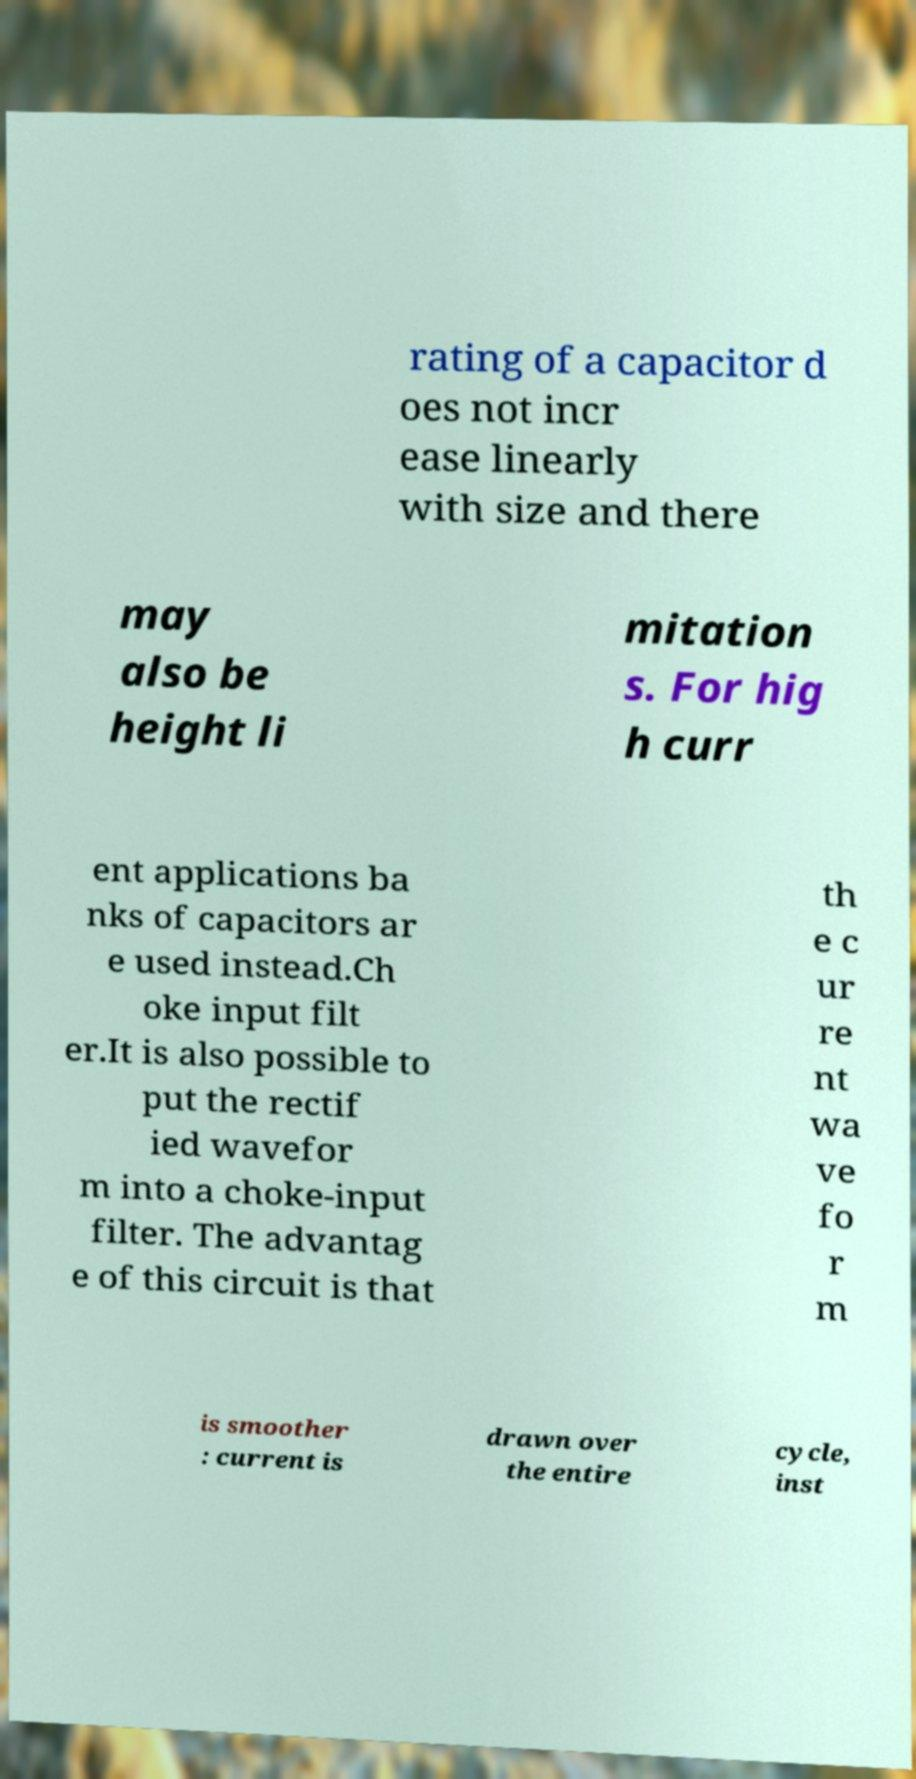Can you accurately transcribe the text from the provided image for me? rating of a capacitor d oes not incr ease linearly with size and there may also be height li mitation s. For hig h curr ent applications ba nks of capacitors ar e used instead.Ch oke input filt er.It is also possible to put the rectif ied wavefor m into a choke-input filter. The advantag e of this circuit is that th e c ur re nt wa ve fo r m is smoother : current is drawn over the entire cycle, inst 